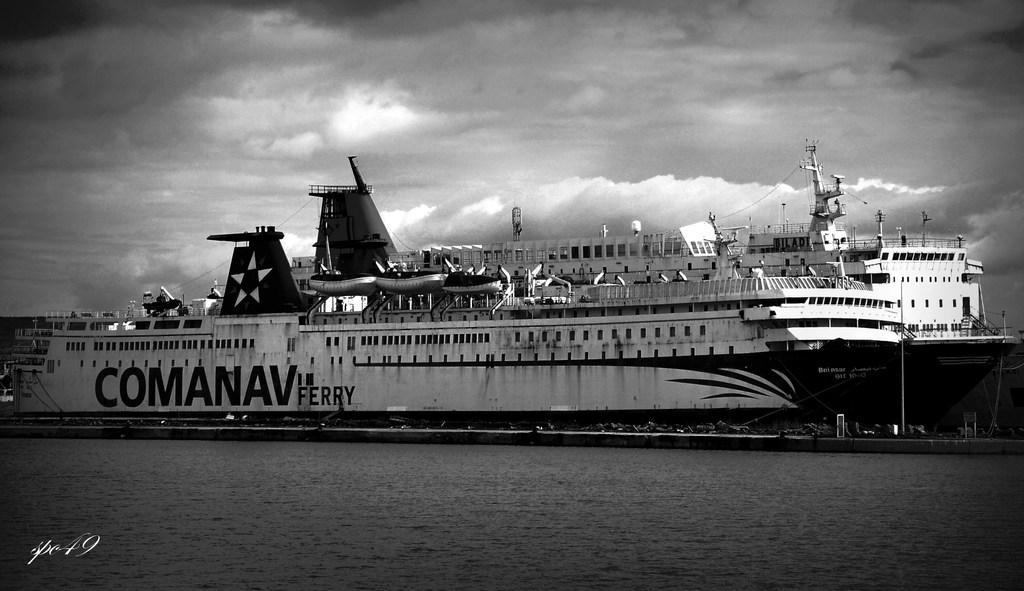<image>
Relay a brief, clear account of the picture shown. A picture of a ship at dock labeled Comanav Ferry. 